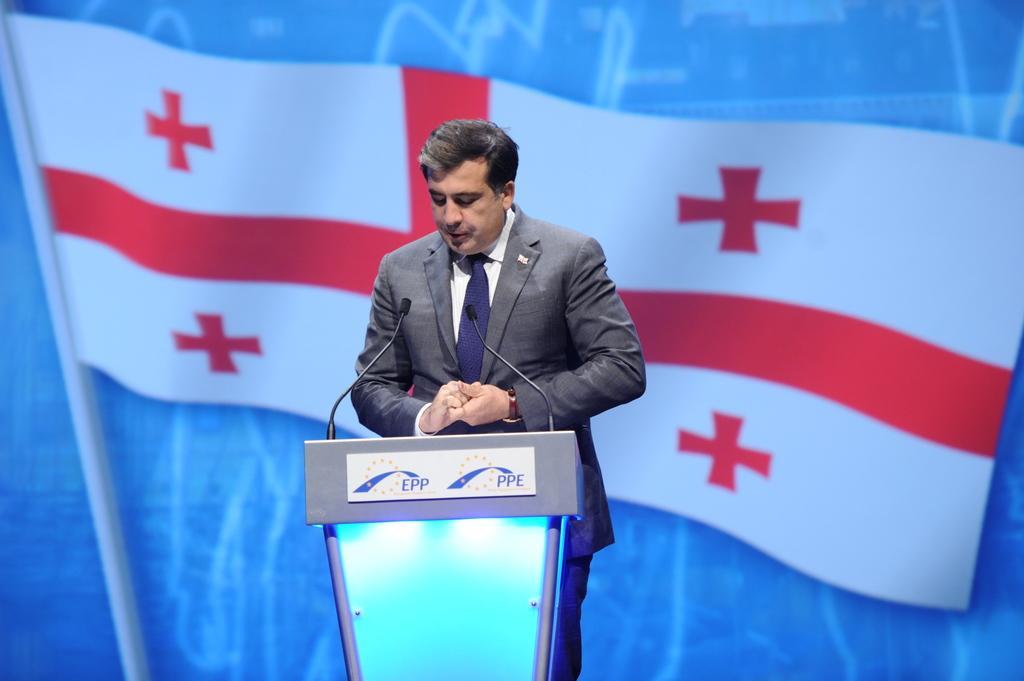Can you describe this image briefly? In this image I can see a man is standing. I can see he is wearing a watch and formal dress. I can also see podium and few mic over here. In the background I can see depiction of a flag. 